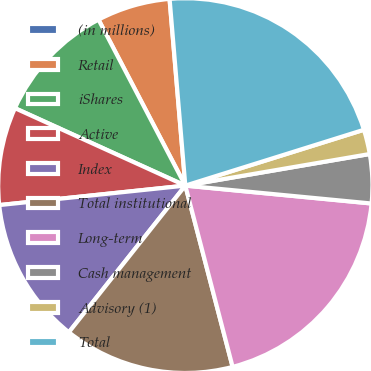<chart> <loc_0><loc_0><loc_500><loc_500><pie_chart><fcel>(in millions)<fcel>Retail<fcel>iShares<fcel>Active<fcel>Index<fcel>Total institutional<fcel>Long-term<fcel>Cash management<fcel>Advisory (1)<fcel>Total<nl><fcel>0.01%<fcel>6.33%<fcel>10.54%<fcel>8.44%<fcel>12.65%<fcel>14.76%<fcel>19.41%<fcel>4.22%<fcel>2.12%<fcel>21.52%<nl></chart> 